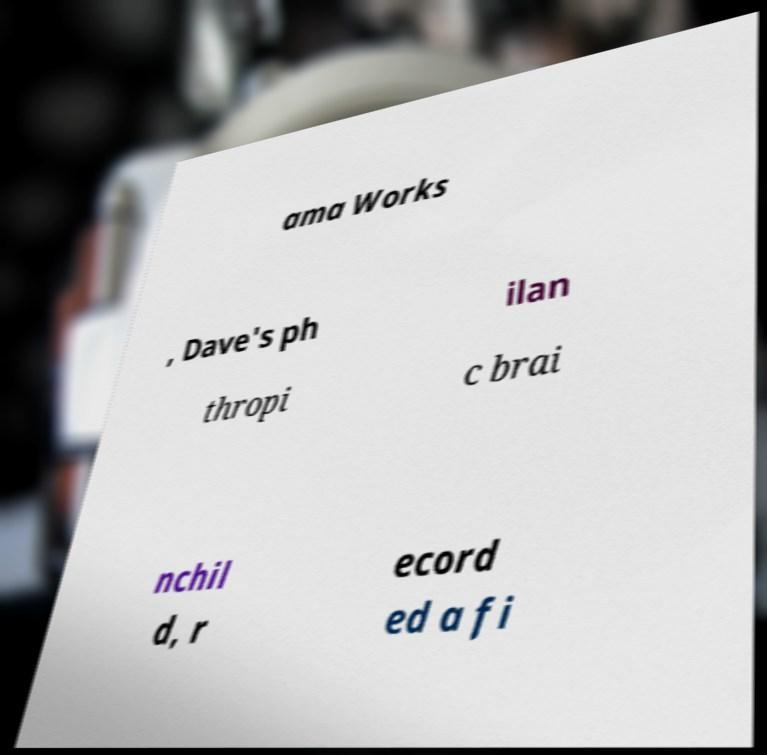I need the written content from this picture converted into text. Can you do that? ama Works , Dave's ph ilan thropi c brai nchil d, r ecord ed a fi 